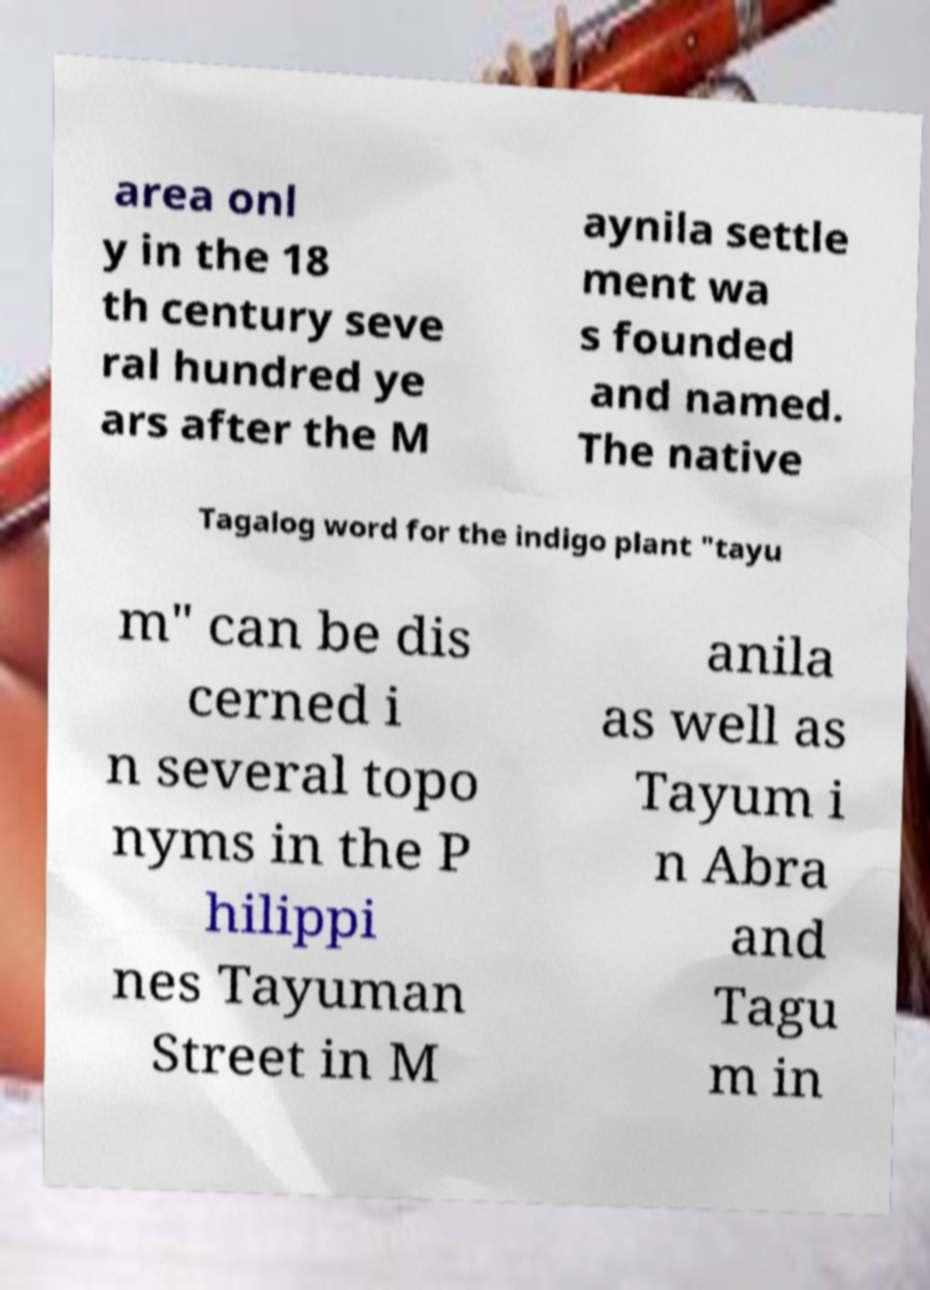Can you read and provide the text displayed in the image?This photo seems to have some interesting text. Can you extract and type it out for me? area onl y in the 18 th century seve ral hundred ye ars after the M aynila settle ment wa s founded and named. The native Tagalog word for the indigo plant "tayu m" can be dis cerned i n several topo nyms in the P hilippi nes Tayuman Street in M anila as well as Tayum i n Abra and Tagu m in 